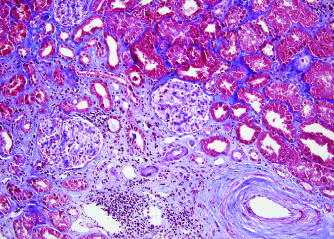what shows fibrosis in this trichrome stain?
Answer the question using a single word or phrase. The blue area 